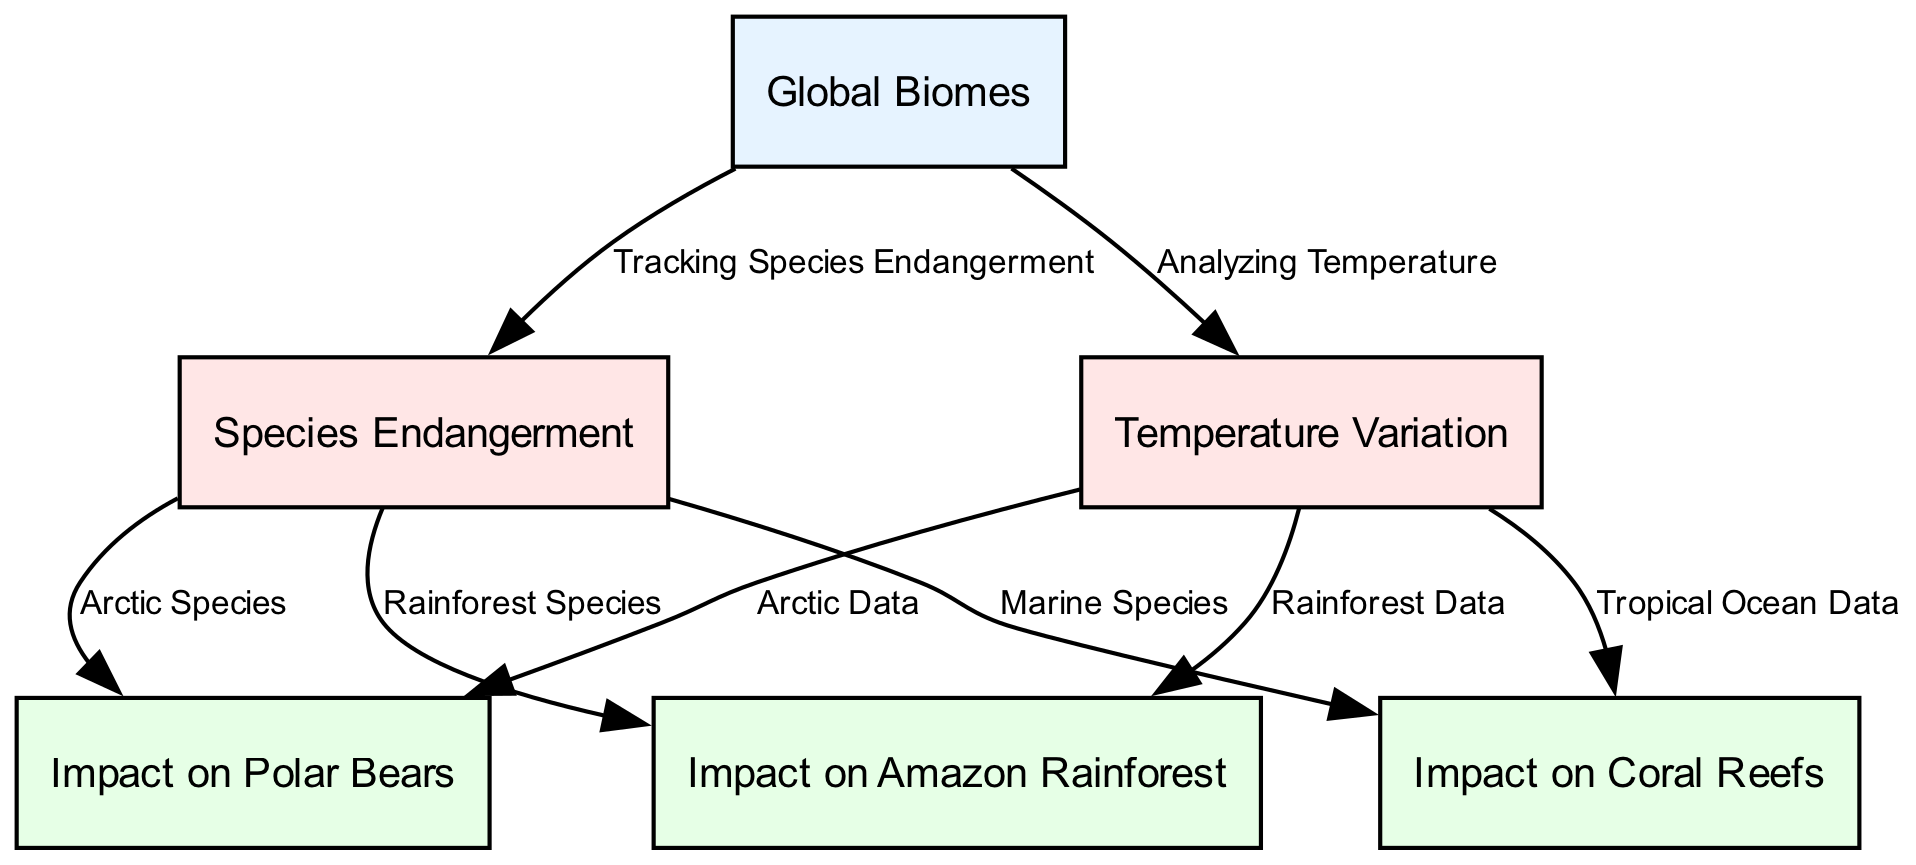What is the label of the first node? The first node listed is of type "geographic_overlay" and is labeled "Global Biomes". Therefore, the label of the first node is "Global Biomes".
Answer: Global Biomes How many bar charts are present in the diagram? The diagram contains two bar charts: one for temperature variation and the other for species endangerment. Adding these together gives a total of two bar charts.
Answer: 2 What type of wildlife impact is associated with rising temperatures in the Arctic? The node connected to the Arctic data highlights the impact on polar bears with a description focusing on their population decline due to increasing temperatures. Therefore, the associated wildlife is "polar bears".
Answer: polar bears Which biome has the highest percentage increase in endangered species according to the diagram? To determine this, one would look at the bar chart for species endangerment, identify the tallest bar, and ascertain its corresponding biome. After analyzing, if the Tropical Rainforest has this tallest bar, it indicates this biome has the highest percentage increase.
Answer: Tropical Rainforest How does the temperature variation in the Temperate Forest compare to the Tundra? By examining the bar chart for temperature variation, one can see the height of the bars corresponding to the Temperate Forest and Tundra. If the bar for the Temperate Forest is higher, it indicates a greater temperature variation compared to the Tundra.
Answer: Greater for Temperate Forest What is the connection between the bar chart of temperature variation and the impact on coral reefs? The diagram indicates an edge connecting the temperature variation to coral reef data, meaning the rising temperatures as indicated in the bar chart directly affect the coral reefs. The impact on coral reefs can thus be seen as a consequence of temperature changes.
Answer: Coral bleaching Which wildlife is affected by habitat loss in the Amazon Rainforest? The diagram clearly states that habitat loss in the Amazon Rainforest is impacting species like the Jaguar. Thus, the wildlife impacted due to habitat loss in this instance would be "Jaguar".
Answer: Jaguar What relationship does the "Tracking Species Endangerment" chart have with polar bear population decline? The "Tracking Species Endangerment" node is directly connected to the polar bear data, indicating that the increase in endangered species directly correlates with the population decline of polar bears due to climate change.
Answer: Direct correlation Which biome has been indicated to suffer from coral bleaching events? By looking at the wildlife impact node that describes coral reefs, it explicitly mentions coral bleaching events occurring in "Tropical Oceans", which corresponds to the Tropical Rainforest biome.
Answer: Tropical Oceans 